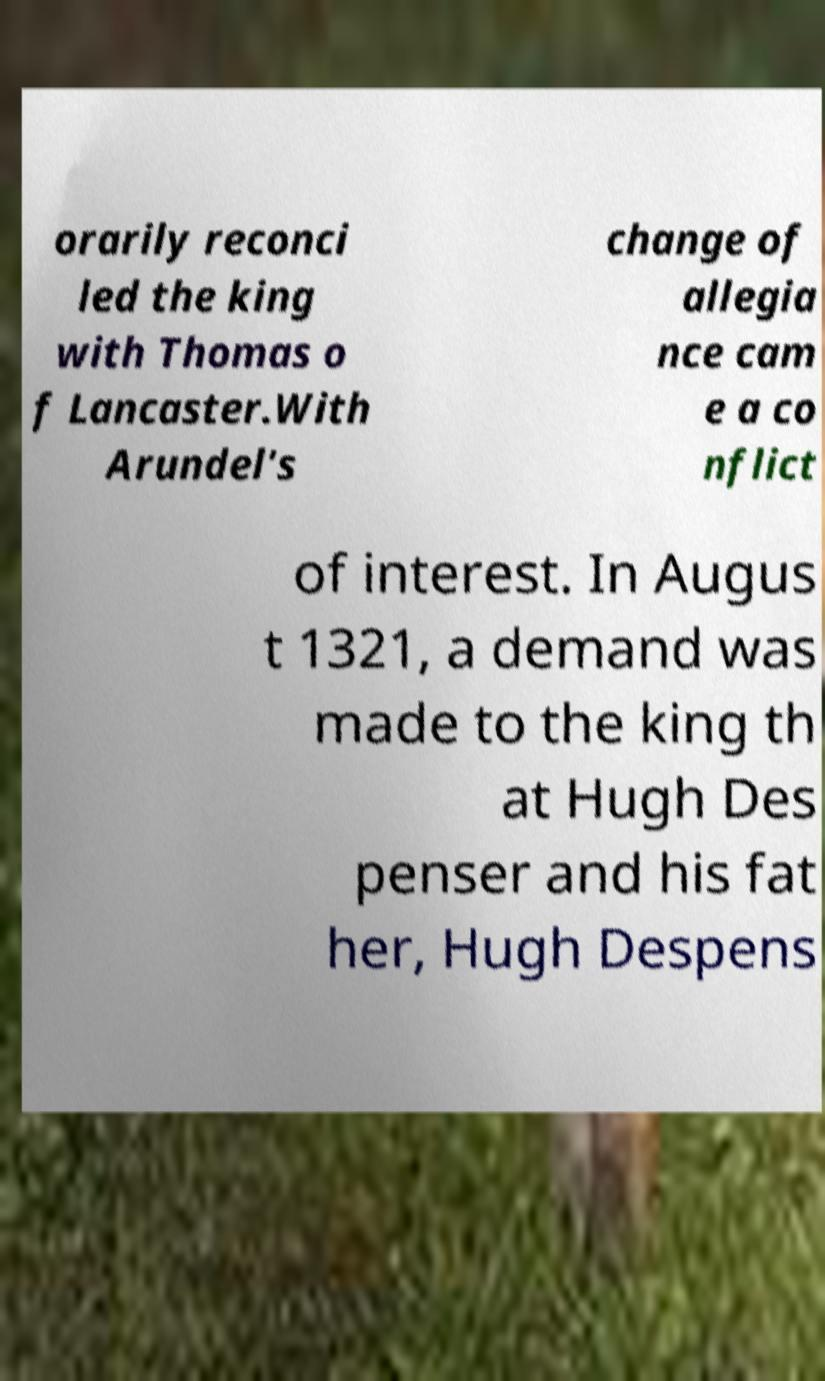Can you read and provide the text displayed in the image?This photo seems to have some interesting text. Can you extract and type it out for me? orarily reconci led the king with Thomas o f Lancaster.With Arundel's change of allegia nce cam e a co nflict of interest. In Augus t 1321, a demand was made to the king th at Hugh Des penser and his fat her, Hugh Despens 